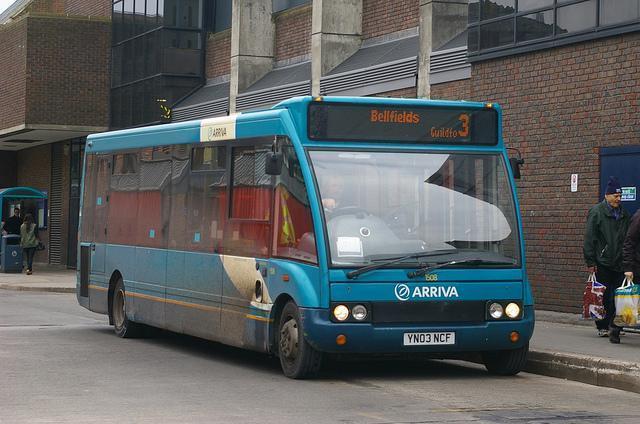How was the man able to get the plastic bags he is carrying?
Choose the right answer from the provided options to respond to the question.
Options: By shopping, by stealing, by dodging, by weaving. By shopping. 